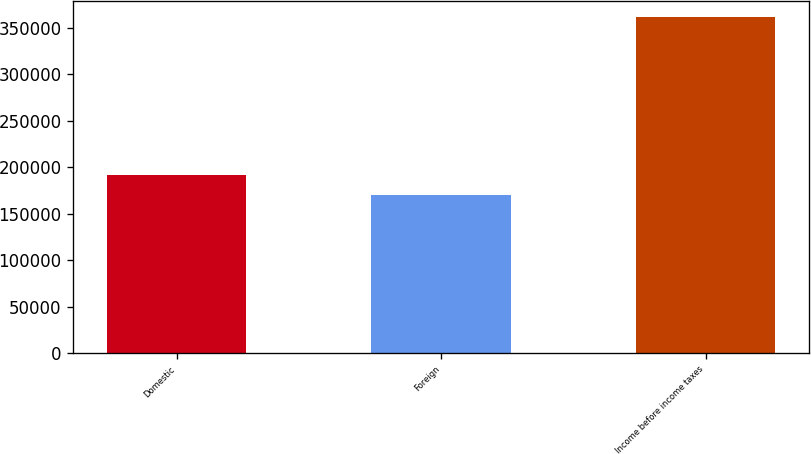<chart> <loc_0><loc_0><loc_500><loc_500><bar_chart><fcel>Domestic<fcel>Foreign<fcel>Income before income taxes<nl><fcel>191563<fcel>169813<fcel>361376<nl></chart> 